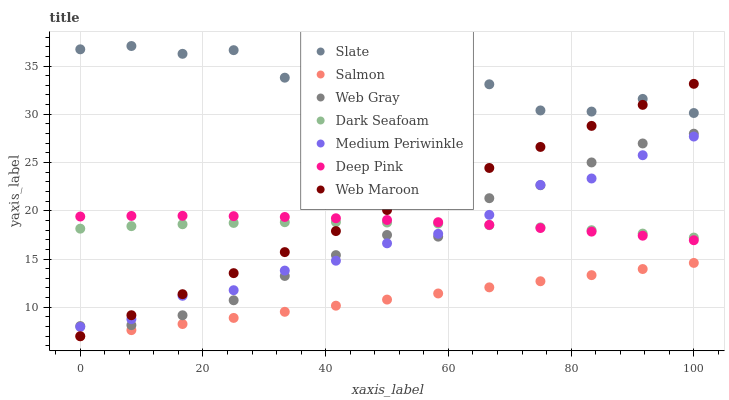Does Salmon have the minimum area under the curve?
Answer yes or no. Yes. Does Slate have the maximum area under the curve?
Answer yes or no. Yes. Does Slate have the minimum area under the curve?
Answer yes or no. No. Does Salmon have the maximum area under the curve?
Answer yes or no. No. Is Salmon the smoothest?
Answer yes or no. Yes. Is Slate the roughest?
Answer yes or no. Yes. Is Slate the smoothest?
Answer yes or no. No. Is Salmon the roughest?
Answer yes or no. No. Does Salmon have the lowest value?
Answer yes or no. Yes. Does Slate have the lowest value?
Answer yes or no. No. Does Slate have the highest value?
Answer yes or no. Yes. Does Salmon have the highest value?
Answer yes or no. No. Is Web Gray less than Slate?
Answer yes or no. Yes. Is Slate greater than Web Gray?
Answer yes or no. Yes. Does Slate intersect Web Maroon?
Answer yes or no. Yes. Is Slate less than Web Maroon?
Answer yes or no. No. Is Slate greater than Web Maroon?
Answer yes or no. No. Does Web Gray intersect Slate?
Answer yes or no. No. 